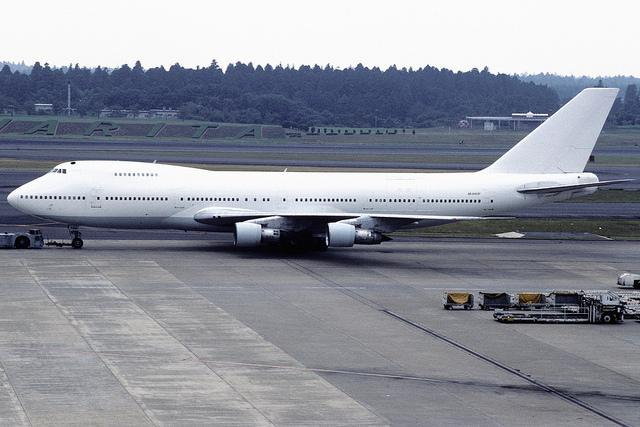Why is there no logo on the plane?

Choices:
A) no money
B) not finished
C) other side
D) secret not finished 